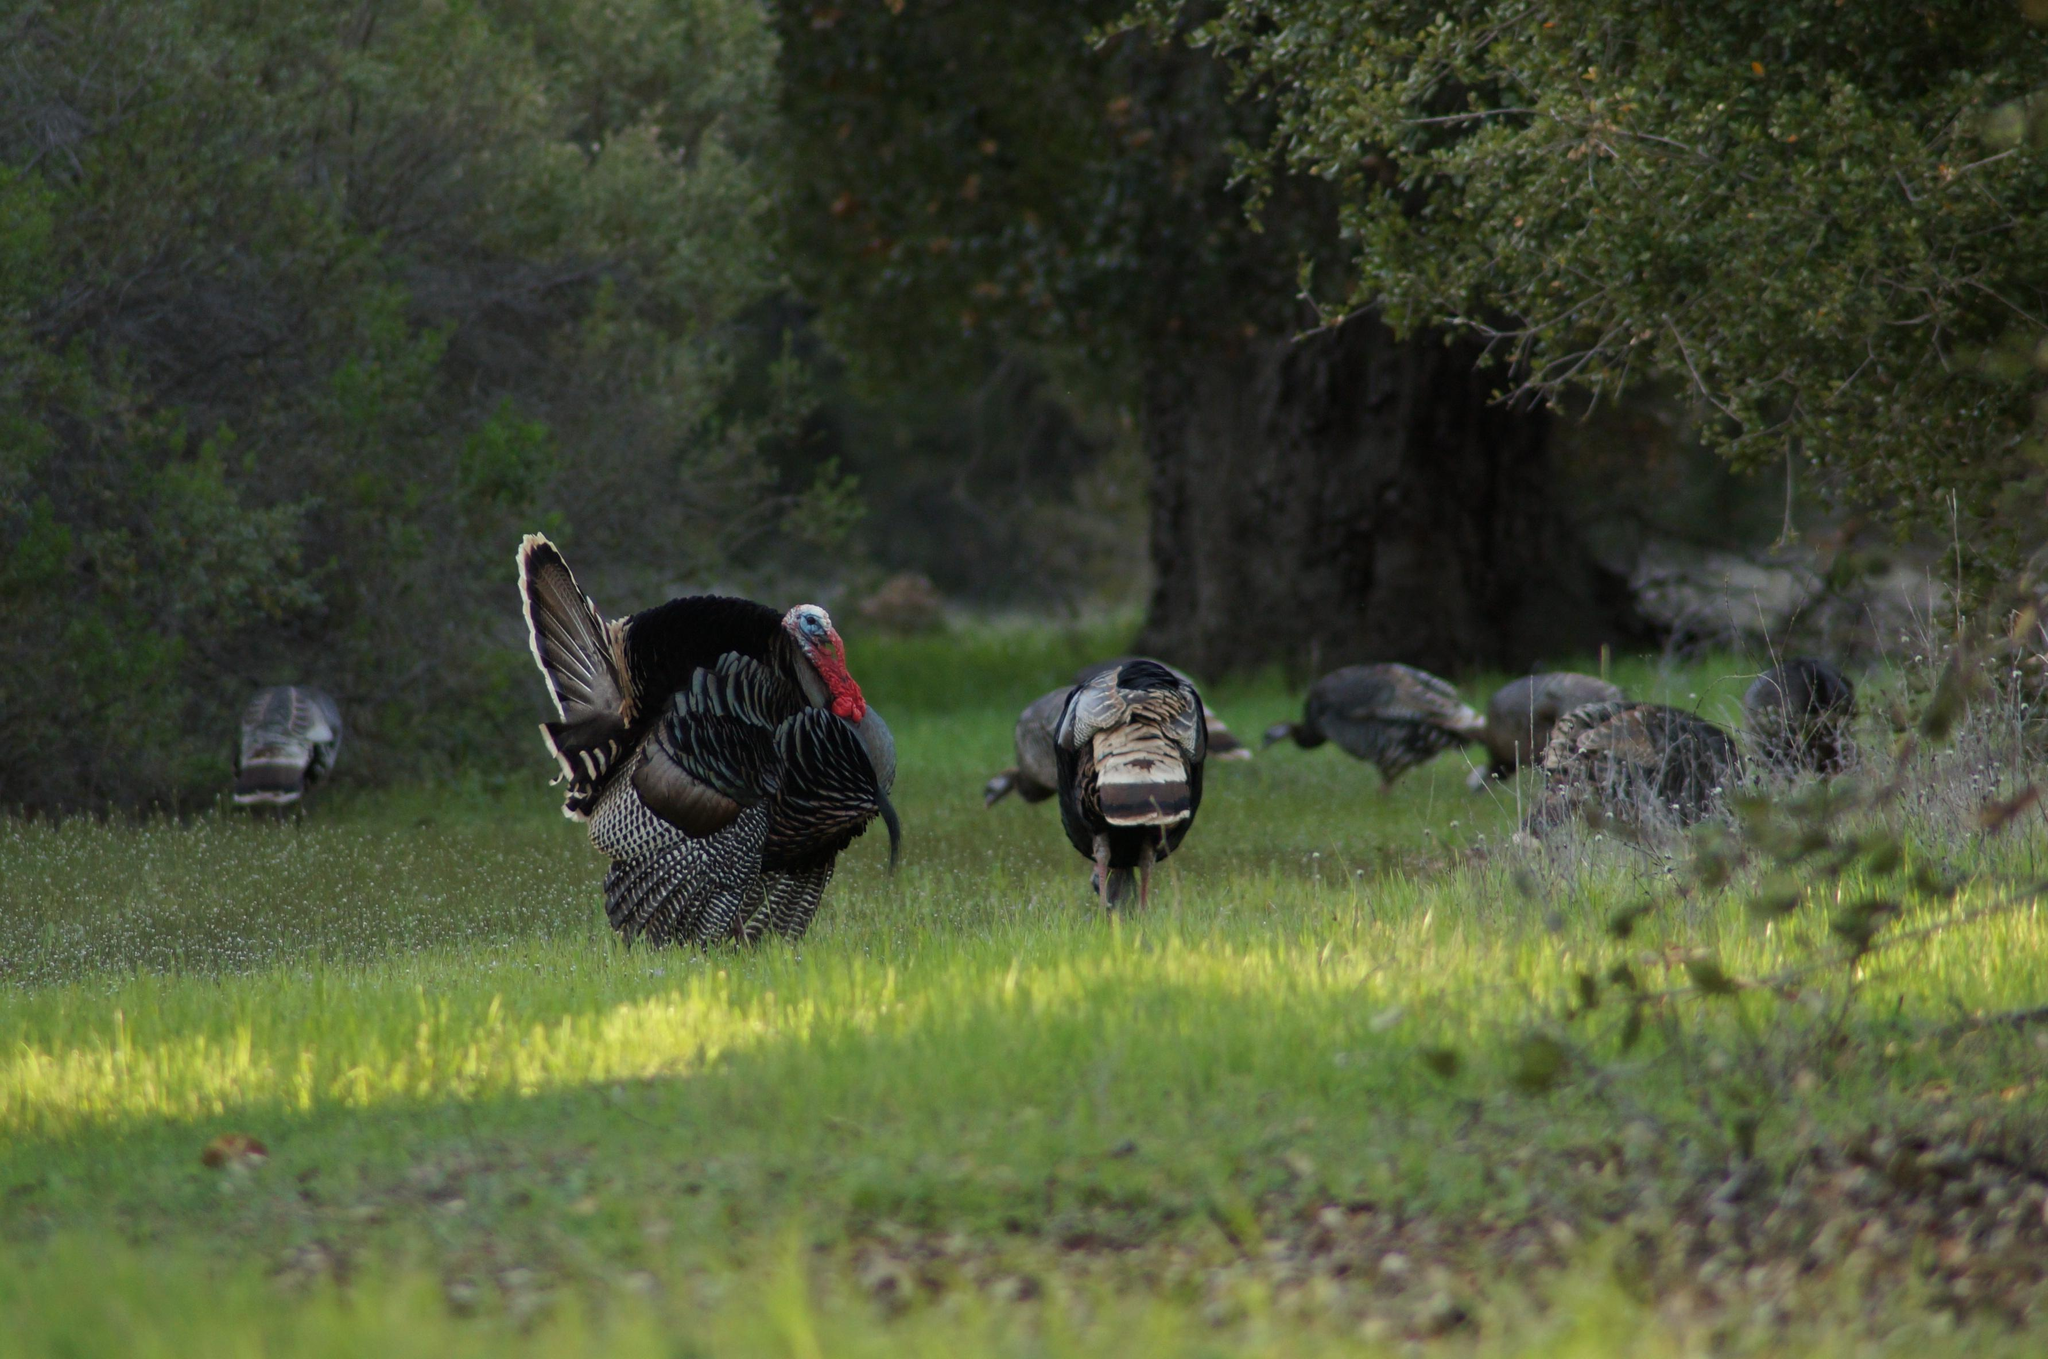What animals are present in the image? There are many turkeys in the image. Where are the turkeys located? The turkeys are standing on the grass. What type of vegetation is visible in the image? The turkeys are surrounded by trees. How does the belief system of the turkeys affect their behavior in the image? There is no information about the belief system of the turkeys in the image, so it cannot be determined how it affects their behavior. 